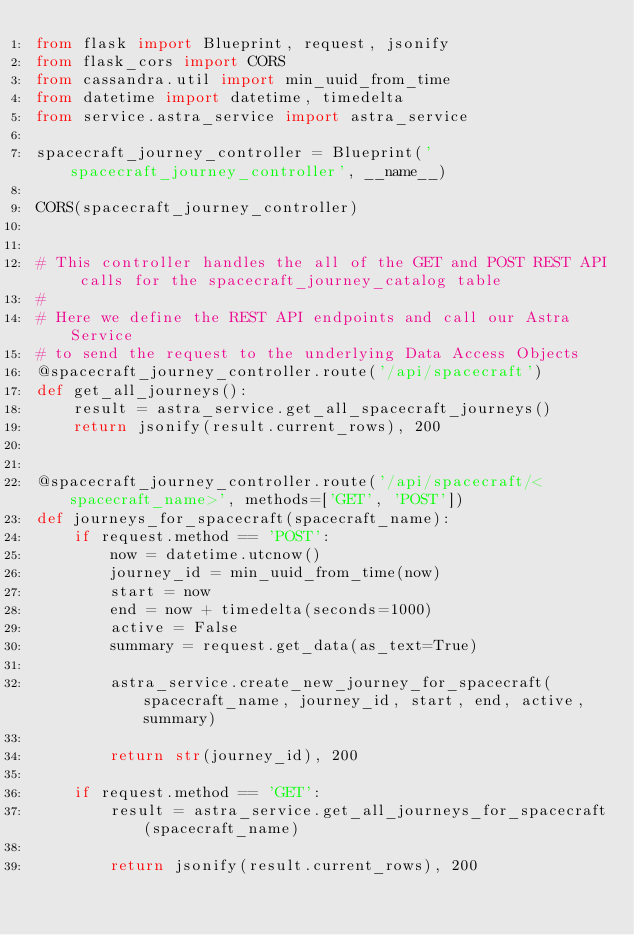<code> <loc_0><loc_0><loc_500><loc_500><_Python_>from flask import Blueprint, request, jsonify
from flask_cors import CORS
from cassandra.util import min_uuid_from_time
from datetime import datetime, timedelta
from service.astra_service import astra_service

spacecraft_journey_controller = Blueprint('spacecraft_journey_controller', __name__)

CORS(spacecraft_journey_controller)


# This controller handles the all of the GET and POST REST API calls for the spacecraft_journey_catalog table
#
# Here we define the REST API endpoints and call our Astra Service
# to send the request to the underlying Data Access Objects
@spacecraft_journey_controller.route('/api/spacecraft')
def get_all_journeys():
    result = astra_service.get_all_spacecraft_journeys()
    return jsonify(result.current_rows), 200


@spacecraft_journey_controller.route('/api/spacecraft/<spacecraft_name>', methods=['GET', 'POST'])
def journeys_for_spacecraft(spacecraft_name):
    if request.method == 'POST':
        now = datetime.utcnow()
        journey_id = min_uuid_from_time(now)
        start = now
        end = now + timedelta(seconds=1000)
        active = False
        summary = request.get_data(as_text=True)

        astra_service.create_new_journey_for_spacecraft(spacecraft_name, journey_id, start, end, active, summary)

        return str(journey_id), 200

    if request.method == 'GET':
        result = astra_service.get_all_journeys_for_spacecraft(spacecraft_name)

        return jsonify(result.current_rows), 200




</code> 